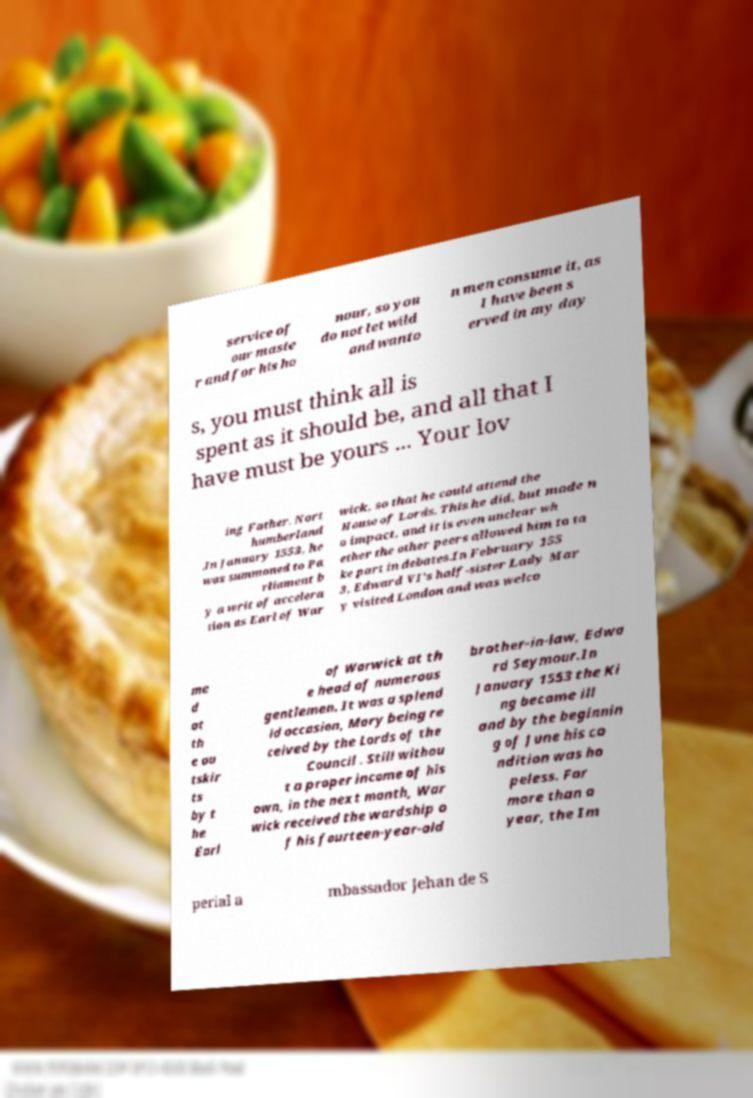For documentation purposes, I need the text within this image transcribed. Could you provide that? service of our maste r and for his ho nour, so you do not let wild and wanto n men consume it, as I have been s erved in my day s, you must think all is spent as it should be, and all that I have must be yours ... Your lov ing Father. Nort humberland .In January 1553, he was summoned to Pa rliament b y a writ of accelera tion as Earl of War wick, so that he could attend the House of Lords. This he did, but made n o impact, and it is even unclear wh ether the other peers allowed him to ta ke part in debates.In February 155 3, Edward VI's half-sister Lady Mar y visited London and was welco me d at th e ou tskir ts by t he Earl of Warwick at th e head of numerous gentlemen. It was a splend id occasion, Mary being re ceived by the Lords of the Council . Still withou t a proper income of his own, in the next month, War wick received the wardship o f his fourteen-year-old brother-in-law, Edwa rd Seymour.In January 1553 the Ki ng became ill and by the beginnin g of June his co ndition was ho peless. For more than a year, the Im perial a mbassador Jehan de S 